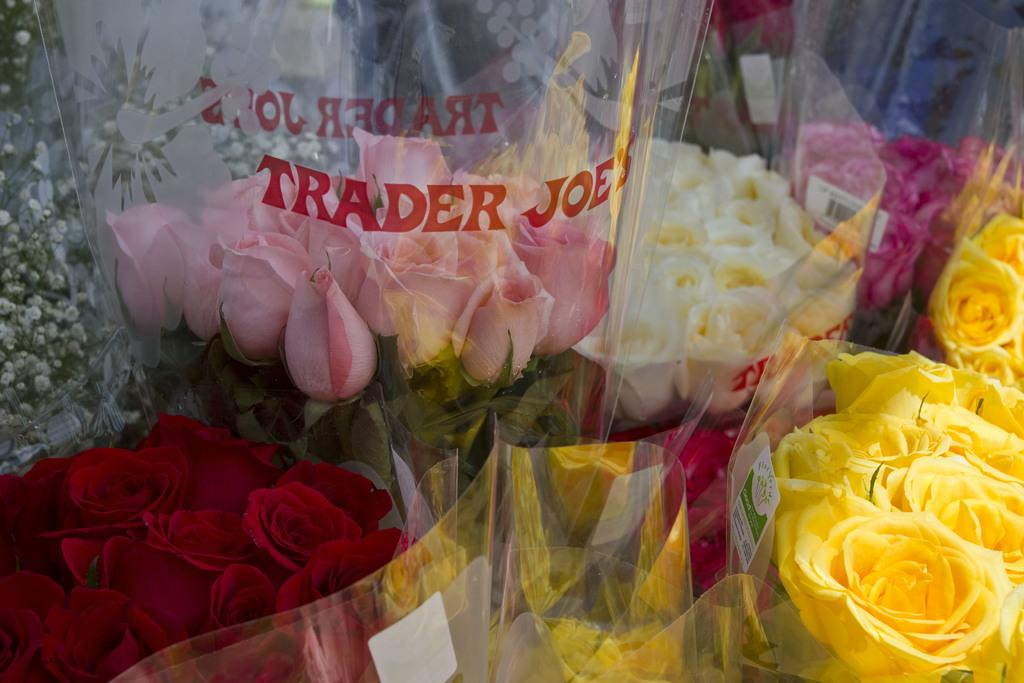What type of flowers are in the image? There are colorful roses in the image. How are the roses protected or contained in the image? The roses are in a plastic cover. What type of rod can be seen holding the roses in the image? There is no rod present in the image; the roses are in a plastic cover. How many beads are attached to the roses in the image? There are no beads attached to the roses in the image; they are simply in a plastic cover. 